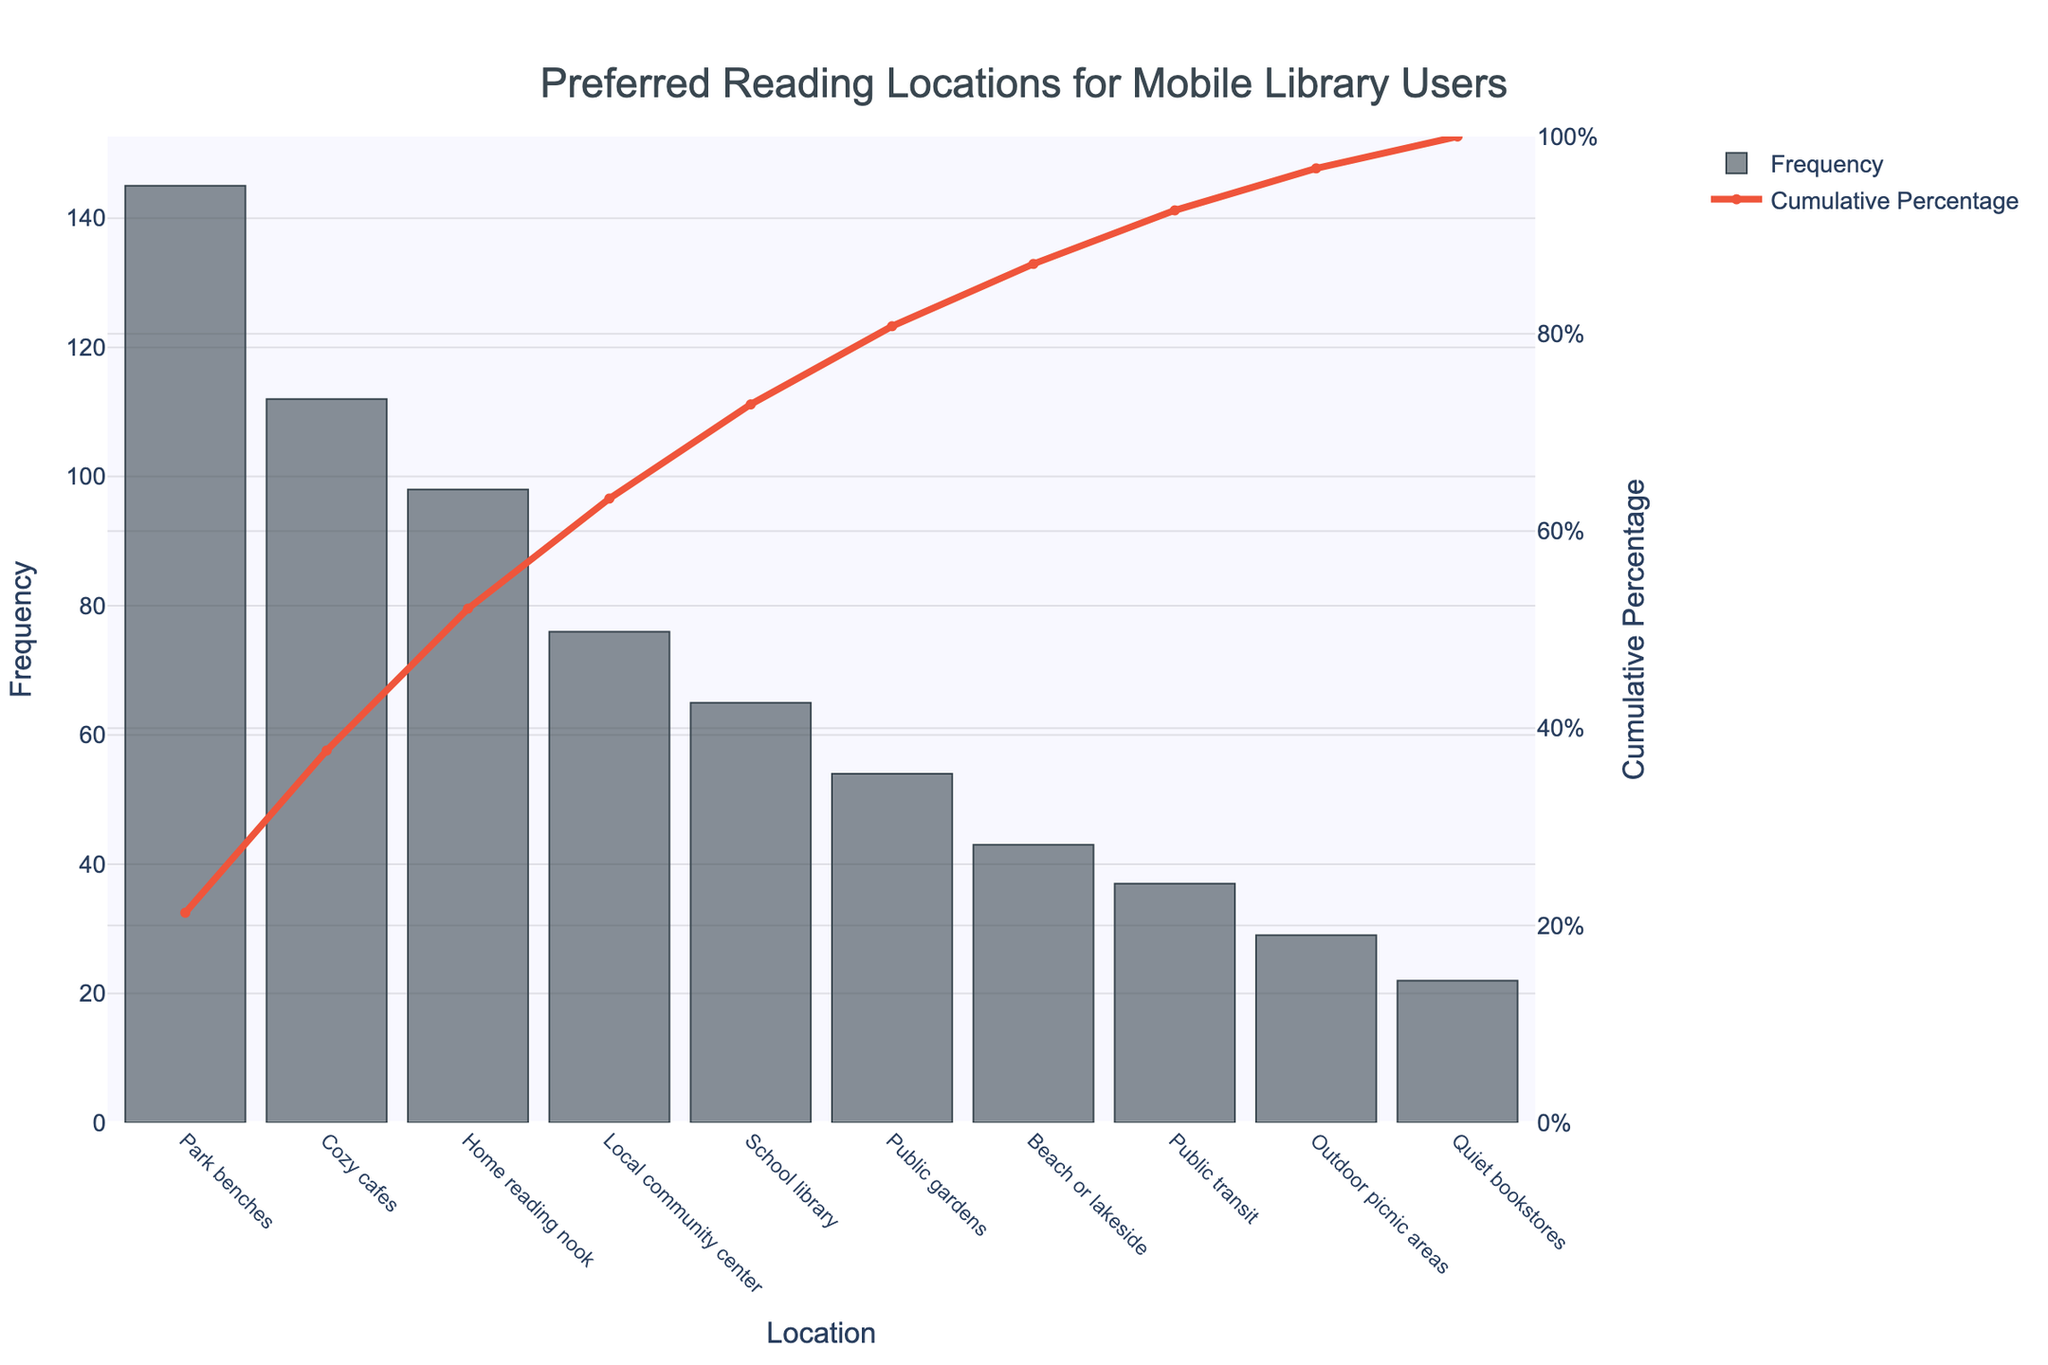What is the title of the figure? The title of the figure is located at the top of the chart. It reads "Preferred Reading Locations for Mobile Library Users."
Answer: Preferred Reading Locations for Mobile Library Users Which reading location has the highest frequency? The highest frequency is represented by the tallest bar in the bar chart. The label corresponding to this bar is "Park benches."
Answer: Park benches What is the cumulative percentage of the top three reading locations? To find this, identify the cumulative percentages at "Park benches," "Cozy cafes," and "Home reading nook." Their values are approximately at 31.67%, 55.19%, and 76.60% respectively. The cumulative percentage of the top three is the one at "Home reading nook."
Answer: 76.60% How many reading locations have a frequency higher than 50? Count the number of bars where the y-value (frequency) is greater than 50. These locations include "Park benches," "Cozy cafes," "Home reading nook," "Local community center," "School library," and "Public gardens."
Answer: 6 Which location ranks fourth in terms of frequency? The fourth tallest bar corresponds to "Local community center," indicating it ranks fourth in frequency.
Answer: Local community center By how much does the frequency of "Cozy cafes" exceed that of "Beach or lakeside"? The frequency of "Cozy cafes" is 112 and the frequency of "Beach or lakeside" is 43. To find the difference, subtract 43 from 112.
Answer: 69 What percentage of users prefer reading at locations other than "Park benches," "Cozy cafes," and "Home reading nook"? The cumulative percentage for these three is 76.60%. Subtract this from 100% to find the remaining percentage.
Answer: 23.4% Which locations have a cumulative percentage between 50% and 75%? Locate the points on the line chart where cumulative percentages are between 50% and 75%. These correspond to "Cozy cafes" and "Home reading nook."
Answer: Cozy cafes, Home reading nook 